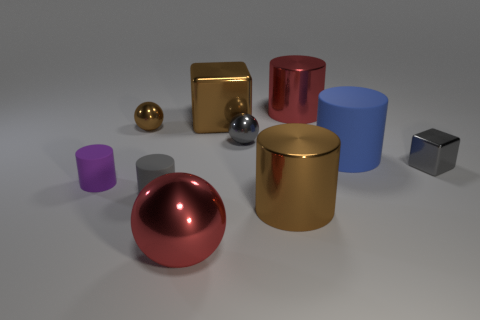Subtract all red cylinders. How many cylinders are left? 4 Subtract all small purple cylinders. How many cylinders are left? 4 Subtract all blocks. How many objects are left? 8 Add 8 blue cylinders. How many blue cylinders exist? 9 Subtract 0 yellow balls. How many objects are left? 10 Subtract 1 blocks. How many blocks are left? 1 Subtract all brown cubes. Subtract all green cylinders. How many cubes are left? 1 Subtract all green cylinders. How many gray balls are left? 1 Subtract all small purple matte cylinders. Subtract all red objects. How many objects are left? 7 Add 9 small metal cubes. How many small metal cubes are left? 10 